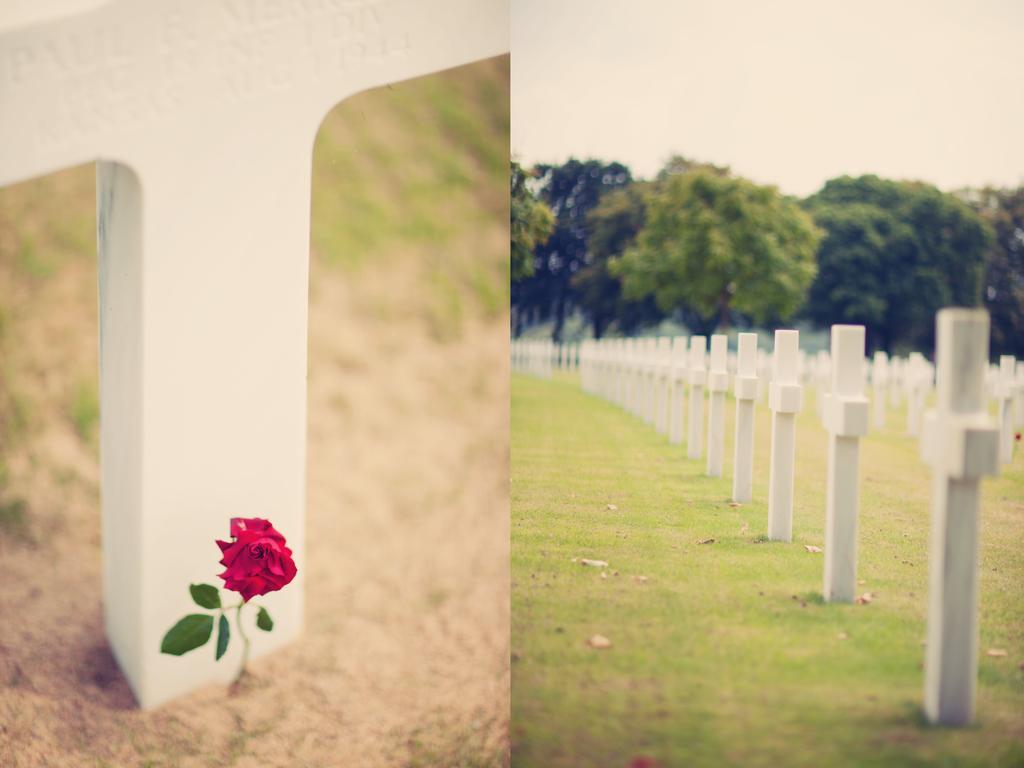In one or two sentences, can you explain what this image depicts? This picture is collage of two images. On the left side there is a flower in the center and there is a white colour stone. On the right side there are stones which are white in colour and there are trees and the sky is cloudy and there is grass on the ground. 